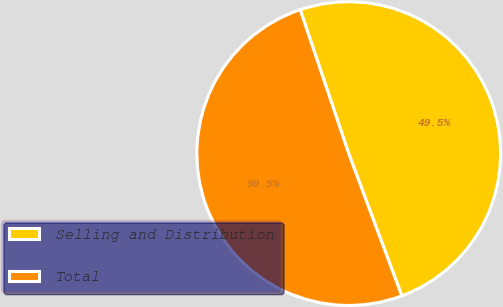Convert chart. <chart><loc_0><loc_0><loc_500><loc_500><pie_chart><fcel>Selling and Distribution<fcel>Total<nl><fcel>49.49%<fcel>50.51%<nl></chart> 